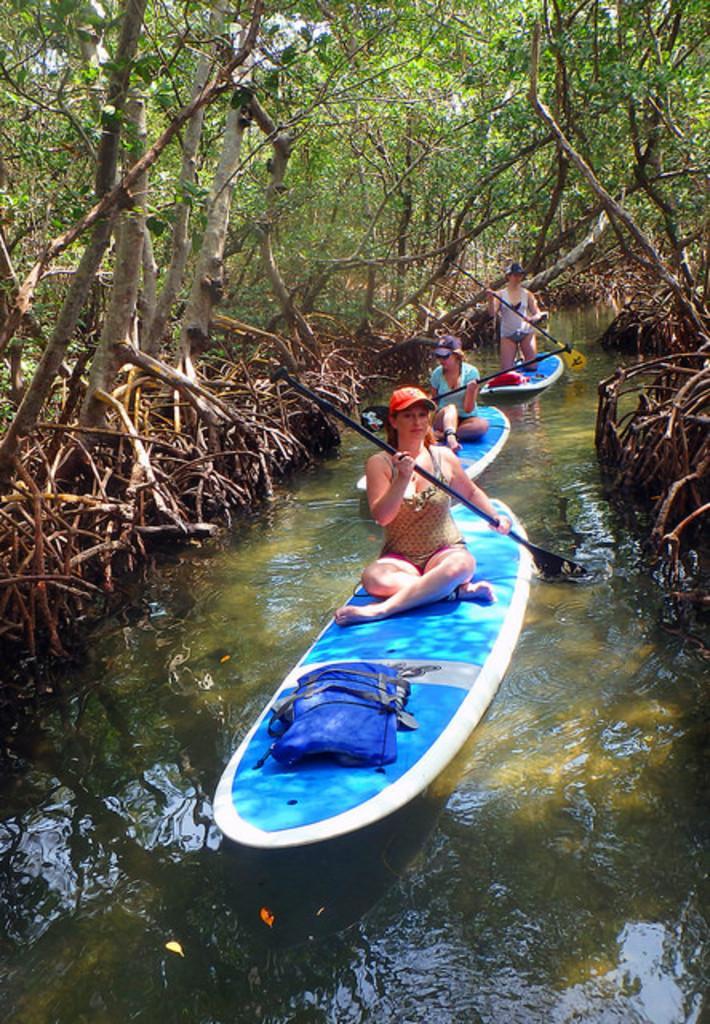Describe this image in one or two sentences. In this image we can see few people rowing boats on the water and there are few trees on the left side of the image. 